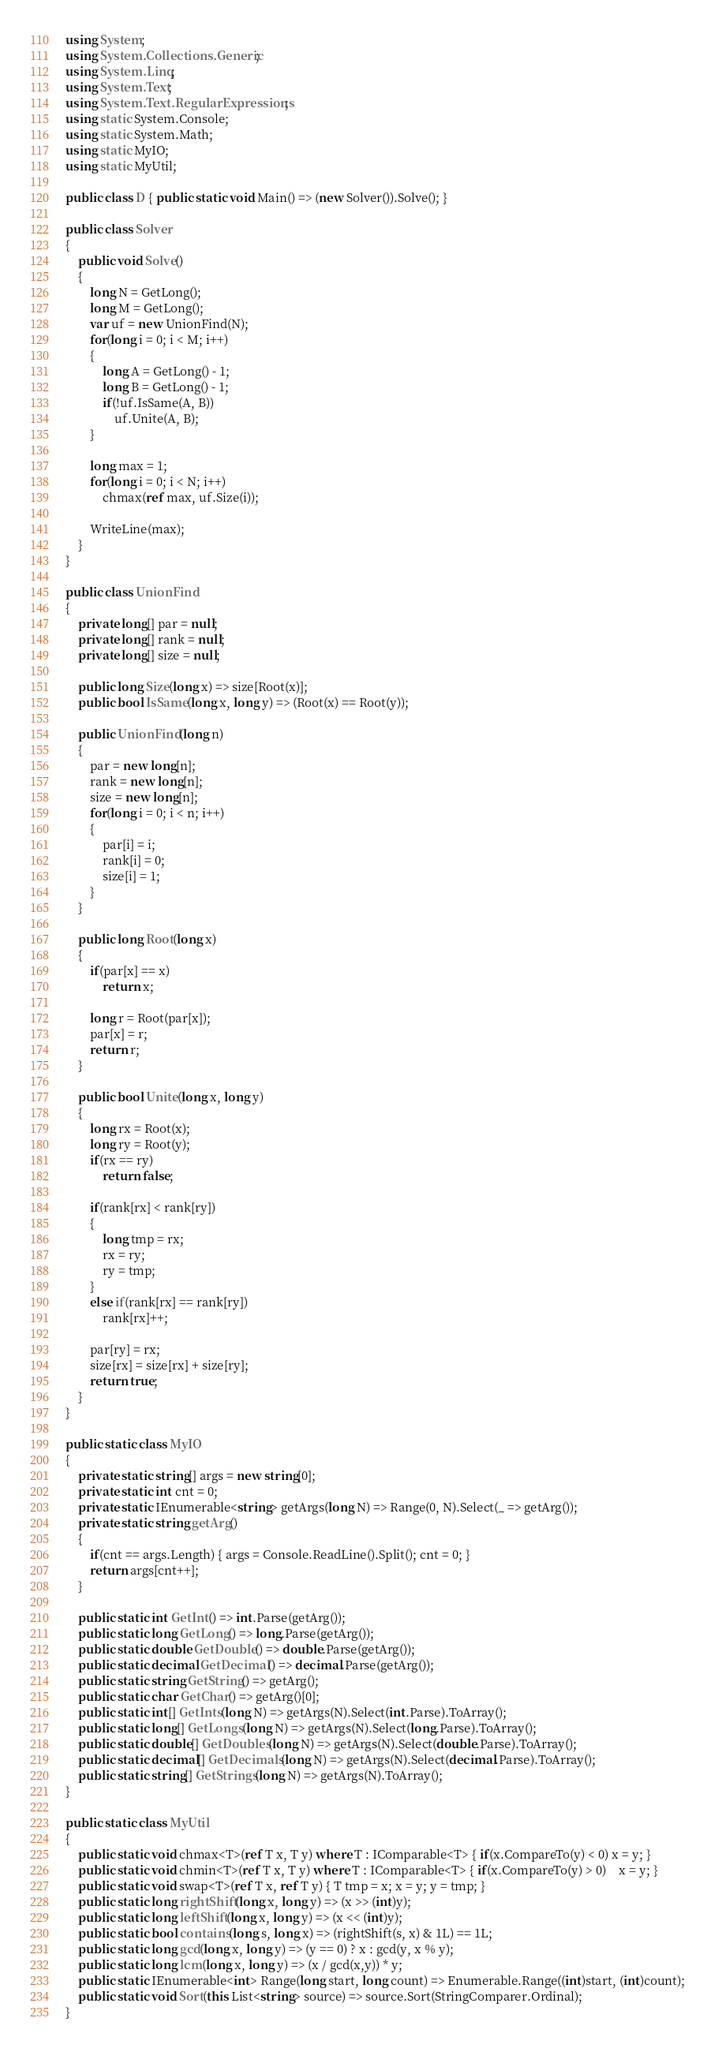Convert code to text. <code><loc_0><loc_0><loc_500><loc_500><_C#_>using System;
using System.Collections.Generic;
using System.Linq;
using System.Text;
using System.Text.RegularExpressions;
using static System.Console;
using static System.Math;
using static MyIO;
using static MyUtil;

public class D { public static void Main() => (new Solver()).Solve(); }

public class Solver
{
	public void Solve()
	{
		long N = GetLong();
		long M = GetLong();
		var uf = new UnionFind(N);
		for(long i = 0; i < M; i++)
		{
			long A = GetLong() - 1;
			long B = GetLong() - 1;
			if(!uf.IsSame(A, B))
				uf.Unite(A, B);
		}

		long max = 1;
		for(long i = 0; i < N; i++)
			chmax(ref max, uf.Size(i));

		WriteLine(max);
	}
}

public class UnionFind
{
	private long[] par = null;
	private long[] rank = null;
	private long[] size = null;
	
	public long Size(long x) => size[Root(x)];
	public bool IsSame(long x, long y) => (Root(x) == Root(y));

	public UnionFind(long n)
	{
		par = new long[n];
		rank = new long[n];
		size = new long[n];
		for(long i = 0; i < n; i++)
		{
			par[i] = i;
			rank[i] = 0;
			size[i] = 1;
		}
	}

	public long Root(long x)
	{
		if(par[x] == x)
			return x;

		long r = Root(par[x]);
		par[x] = r;
		return r;
	}
	
	public bool Unite(long x, long y)
	{
		long rx = Root(x);
		long ry = Root(y);
		if(rx == ry)
			return false;
		
		if(rank[rx] < rank[ry])
		{
			long tmp = rx;
			rx = ry;
			ry = tmp;
		}
		else if(rank[rx] == rank[ry])
			rank[rx]++;

		par[ry] = rx;
		size[rx] = size[rx] + size[ry];
		return true;
	}
}

public static class MyIO
{
	private static string[] args = new string[0];
	private static int cnt = 0;
	private static IEnumerable<string> getArgs(long N) => Range(0, N).Select(_ => getArg());
	private static string getArg()
	{
		if(cnt == args.Length) { args = Console.ReadLine().Split(); cnt = 0; }
		return args[cnt++];
	}

	public static int GetInt() => int.Parse(getArg());
	public static long GetLong() => long.Parse(getArg());
	public static double GetDouble() => double.Parse(getArg());
	public static decimal GetDecimal() => decimal.Parse(getArg());
	public static string GetString() => getArg();
	public static char GetChar() => getArg()[0];
	public static int[] GetInts(long N) => getArgs(N).Select(int.Parse).ToArray();
	public static long[] GetLongs(long N) => getArgs(N).Select(long.Parse).ToArray();
	public static double[] GetDoubles(long N) => getArgs(N).Select(double.Parse).ToArray();
	public static decimal[] GetDecimals(long N) => getArgs(N).Select(decimal.Parse).ToArray();
	public static string[] GetStrings(long N) => getArgs(N).ToArray();
}

public static class MyUtil
{
	public static void chmax<T>(ref T x, T y) where T : IComparable<T> { if(x.CompareTo(y) < 0) x = y; }
	public static void chmin<T>(ref T x, T y) where T : IComparable<T> { if(x.CompareTo(y) > 0)	x = y; }
	public static void swap<T>(ref T x, ref T y) { T tmp = x; x = y; y = tmp; }
	public static long rightShift(long x, long y) => (x >> (int)y);
	public static long leftShift(long x, long y) => (x << (int)y);
	public static bool contains(long s, long x) => (rightShift(s, x) & 1L) == 1L;
	public static long gcd(long x, long y) => (y == 0) ? x : gcd(y, x % y);
	public static long lcm(long x, long y) => (x / gcd(x,y)) * y;	
	public static IEnumerable<int> Range(long start, long count) => Enumerable.Range((int)start, (int)count);
	public static void Sort(this List<string> source) => source.Sort(StringComparer.Ordinal);
}
</code> 